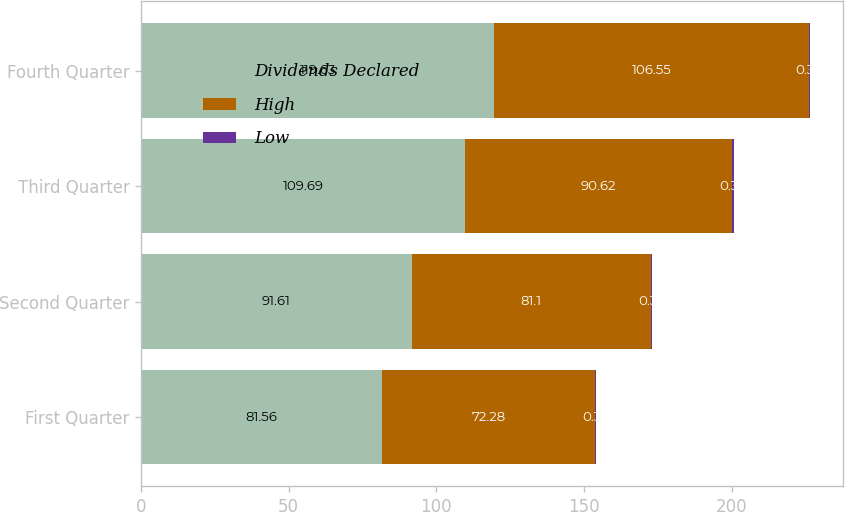Convert chart to OTSL. <chart><loc_0><loc_0><loc_500><loc_500><stacked_bar_chart><ecel><fcel>First Quarter<fcel>Second Quarter<fcel>Third Quarter<fcel>Fourth Quarter<nl><fcel>Dividends Declared<fcel>81.56<fcel>91.61<fcel>109.69<fcel>119.63<nl><fcel>High<fcel>72.28<fcel>81.1<fcel>90.62<fcel>106.55<nl><fcel>Low<fcel>0.36<fcel>0.36<fcel>0.36<fcel>0.36<nl></chart> 